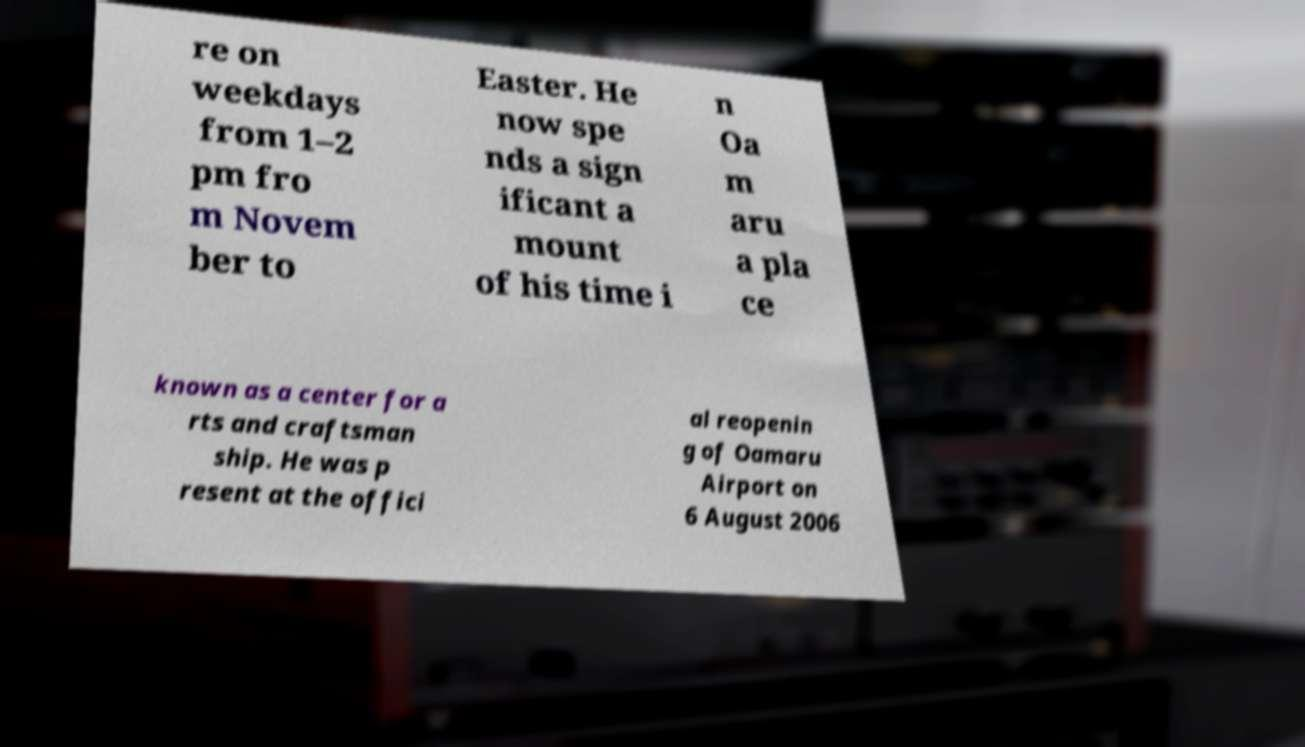Can you read and provide the text displayed in the image?This photo seems to have some interesting text. Can you extract and type it out for me? re on weekdays from 1–2 pm fro m Novem ber to Easter. He now spe nds a sign ificant a mount of his time i n Oa m aru a pla ce known as a center for a rts and craftsman ship. He was p resent at the offici al reopenin g of Oamaru Airport on 6 August 2006 